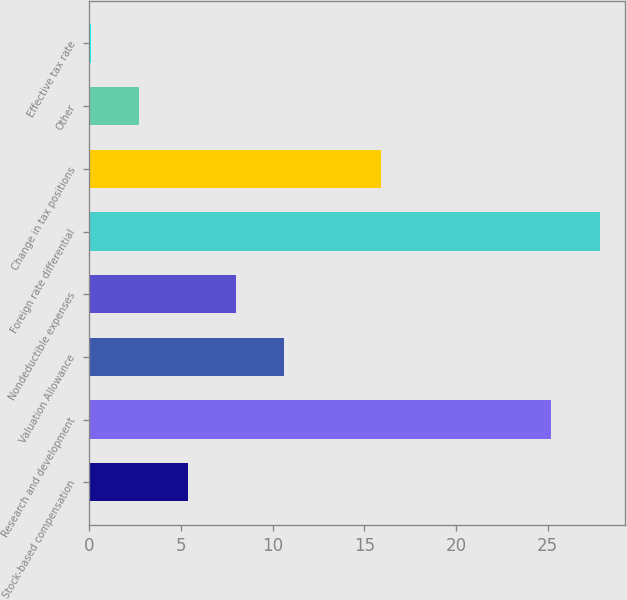<chart> <loc_0><loc_0><loc_500><loc_500><bar_chart><fcel>Stock-based compensation<fcel>Research and development<fcel>Valuation Allowance<fcel>Nondeductible expenses<fcel>Foreign rate differential<fcel>Change in tax positions<fcel>Other<fcel>Effective tax rate<nl><fcel>5.36<fcel>25.2<fcel>10.62<fcel>7.99<fcel>27.83<fcel>15.9<fcel>2.73<fcel>0.1<nl></chart> 